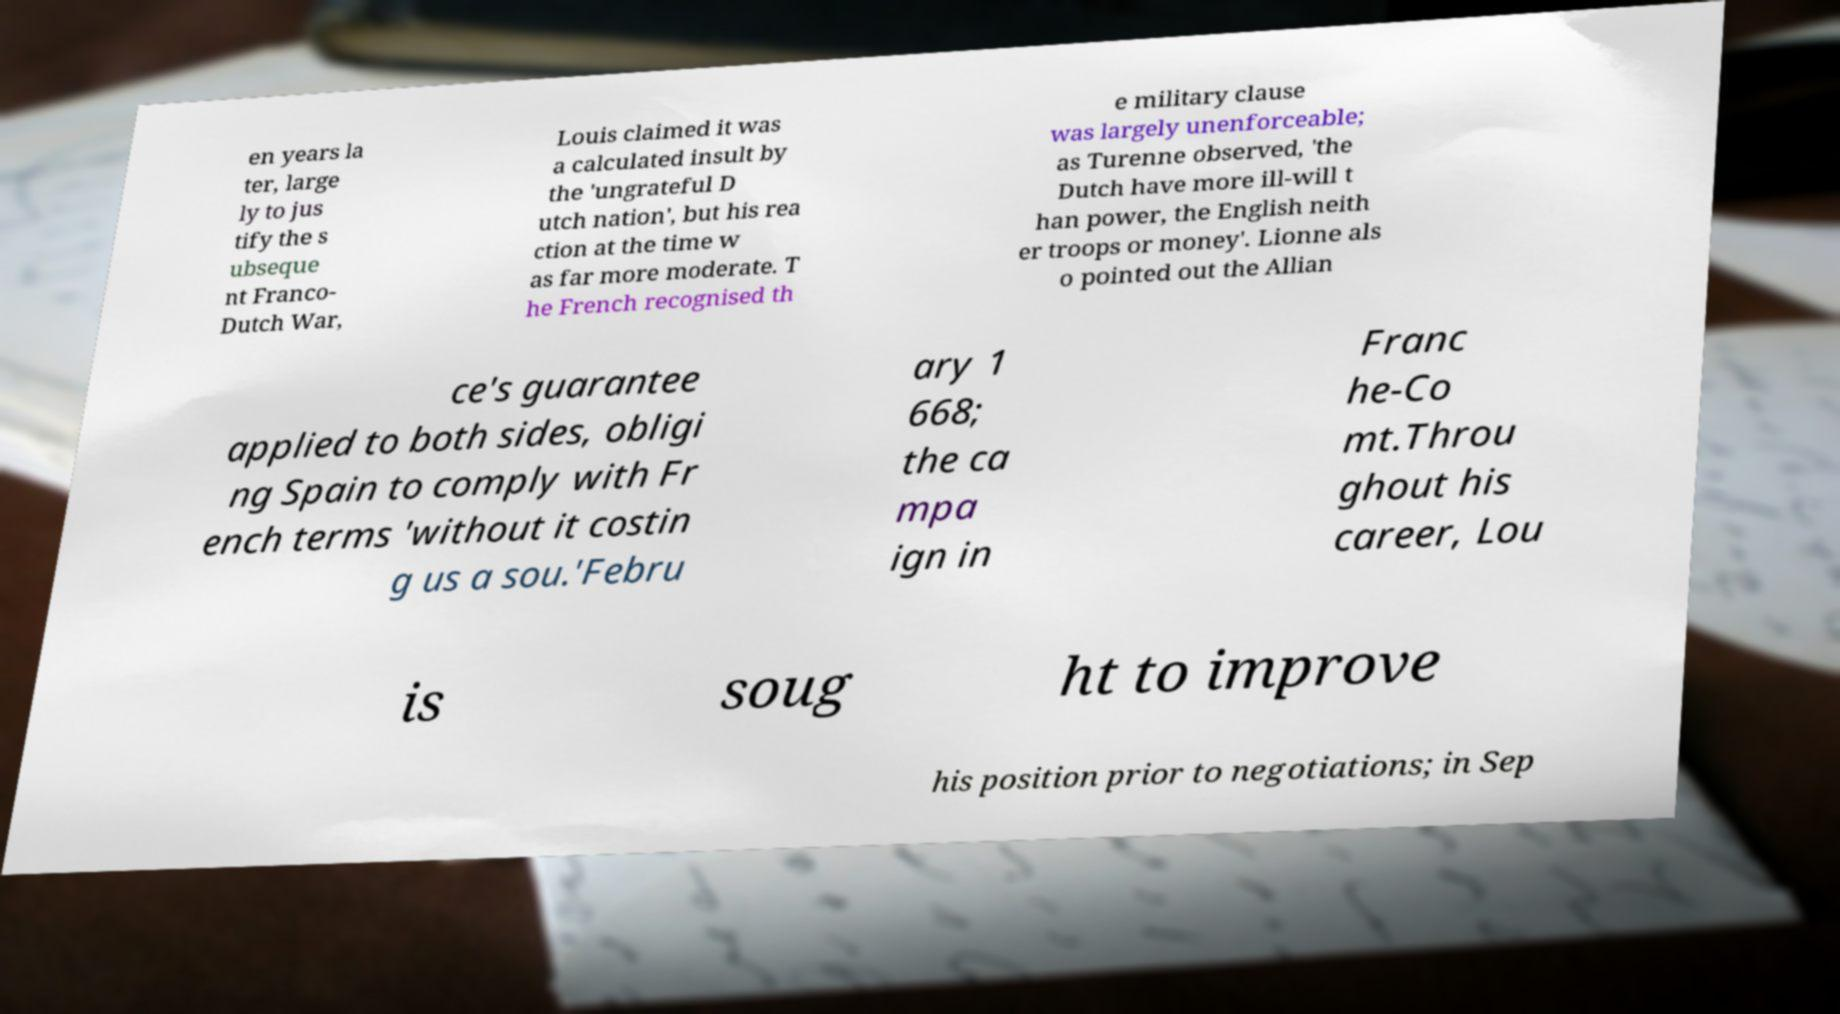Can you accurately transcribe the text from the provided image for me? en years la ter, large ly to jus tify the s ubseque nt Franco- Dutch War, Louis claimed it was a calculated insult by the 'ungrateful D utch nation', but his rea ction at the time w as far more moderate. T he French recognised th e military clause was largely unenforceable; as Turenne observed, 'the Dutch have more ill-will t han power, the English neith er troops or money'. Lionne als o pointed out the Allian ce's guarantee applied to both sides, obligi ng Spain to comply with Fr ench terms 'without it costin g us a sou.'Febru ary 1 668; the ca mpa ign in Franc he-Co mt.Throu ghout his career, Lou is soug ht to improve his position prior to negotiations; in Sep 